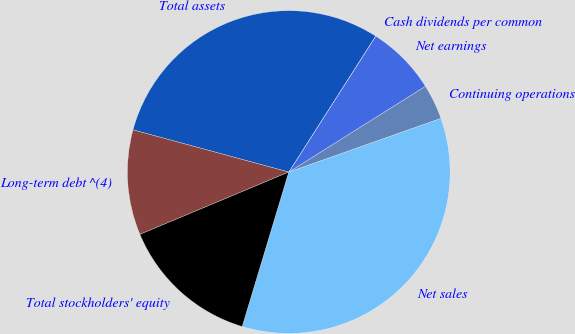Convert chart. <chart><loc_0><loc_0><loc_500><loc_500><pie_chart><fcel>Net sales<fcel>Continuing operations<fcel>Net earnings<fcel>Cash dividends per common<fcel>Total assets<fcel>Long-term debt ^(4)<fcel>Total stockholders' equity<nl><fcel>35.06%<fcel>3.52%<fcel>7.02%<fcel>0.01%<fcel>29.84%<fcel>10.52%<fcel>14.03%<nl></chart> 